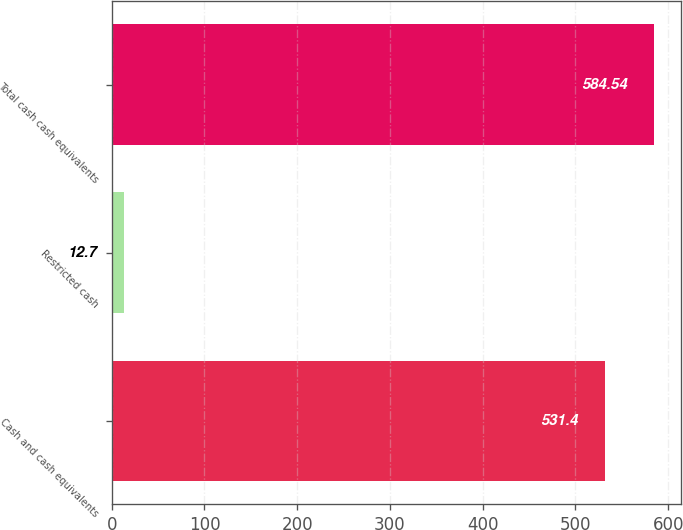Convert chart to OTSL. <chart><loc_0><loc_0><loc_500><loc_500><bar_chart><fcel>Cash and cash equivalents<fcel>Restricted cash<fcel>Total cash cash equivalents<nl><fcel>531.4<fcel>12.7<fcel>584.54<nl></chart> 